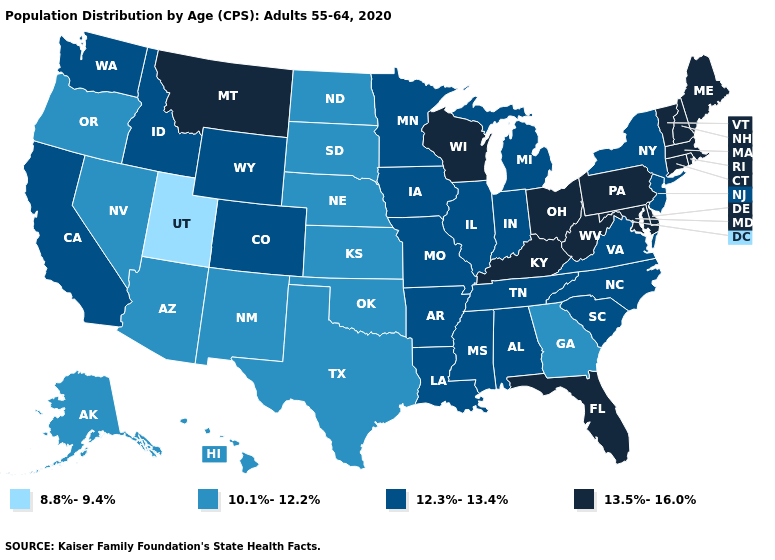Does Georgia have the same value as Oklahoma?
Short answer required. Yes. What is the highest value in the USA?
Give a very brief answer. 13.5%-16.0%. What is the lowest value in states that border New Hampshire?
Keep it brief. 13.5%-16.0%. What is the lowest value in the USA?
Quick response, please. 8.8%-9.4%. What is the lowest value in the USA?
Write a very short answer. 8.8%-9.4%. What is the value of Wisconsin?
Give a very brief answer. 13.5%-16.0%. What is the value of Oklahoma?
Concise answer only. 10.1%-12.2%. What is the value of Michigan?
Answer briefly. 12.3%-13.4%. Does Wyoming have the same value as Michigan?
Keep it brief. Yes. Which states have the lowest value in the USA?
Concise answer only. Utah. Name the states that have a value in the range 8.8%-9.4%?
Be succinct. Utah. What is the value of Arizona?
Concise answer only. 10.1%-12.2%. Which states have the lowest value in the USA?
Answer briefly. Utah. Which states have the lowest value in the South?
Answer briefly. Georgia, Oklahoma, Texas. What is the value of Georgia?
Keep it brief. 10.1%-12.2%. 